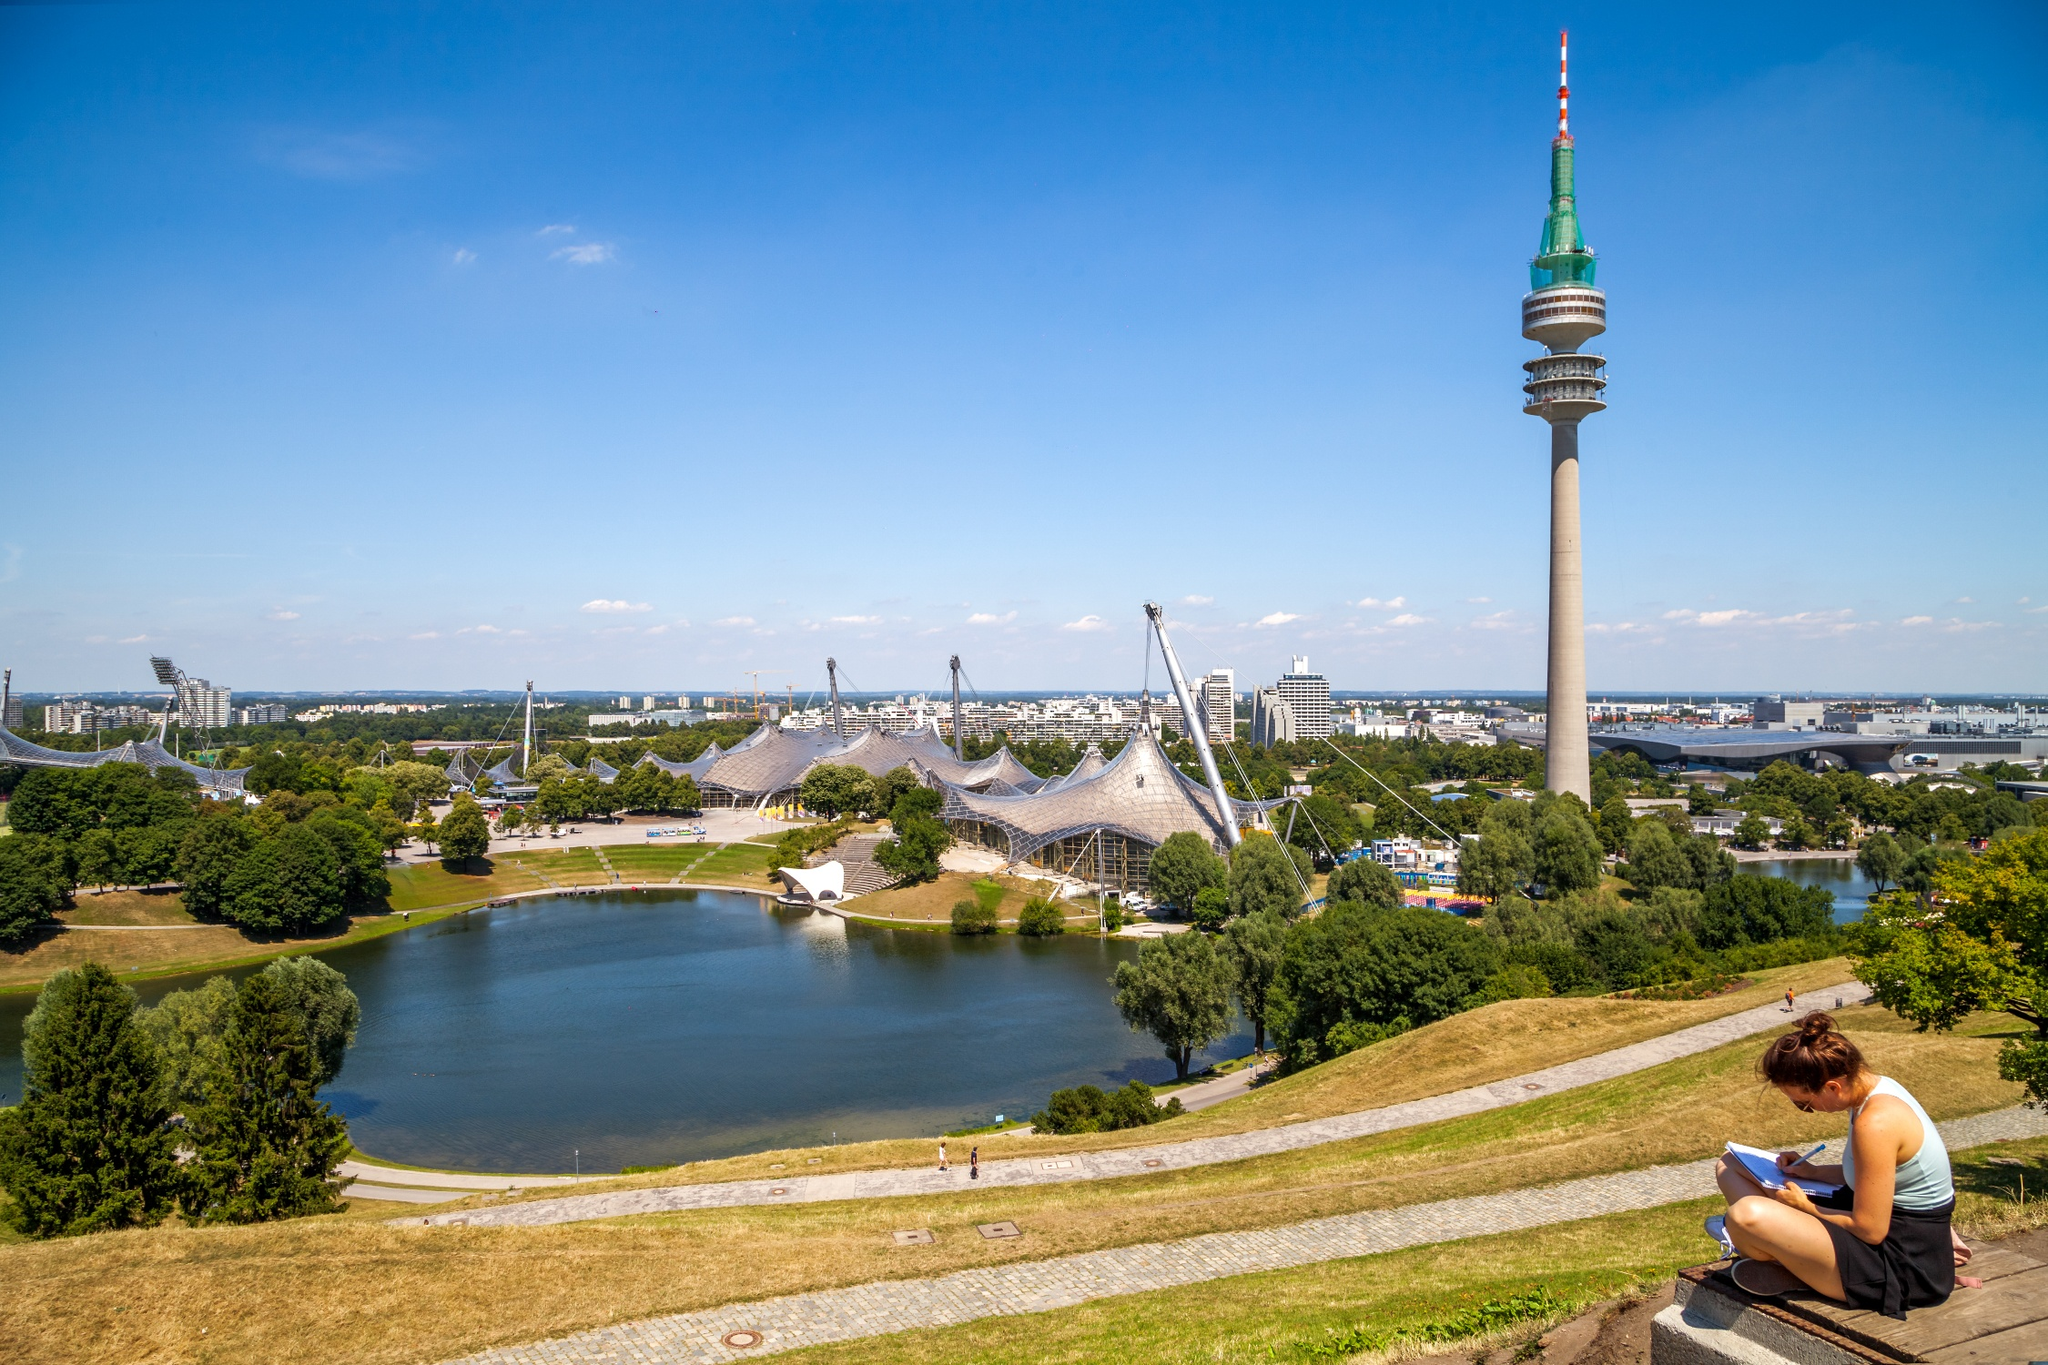Imagine an adventurous scenario unfolding in this park. As the sun sets and the park transitions into a serene twilight, an unexpected adventure unfolds. Out of nowhere, the surrounding greenery starts to shimmer, and the lake glows with a mysterious, ethereal light. Suddenly, a doorway emerges from beneath the Olympic Tower, leading to an ancient subterranean passage. A curious explorer, having stumbled upon a forgotten treasure map, is drawn towards the portal. The map hints at hidden treasure beneath the park, buried centuries ago by an old Bavarian tribe. The explorer, armed with nothing but a flashlight and sheer determination, descends into the unknown, uncovering secrets of the past, encountering hidden chambers, and solving puzzles that protect the legendary fortune of the Bavarian warriors. 